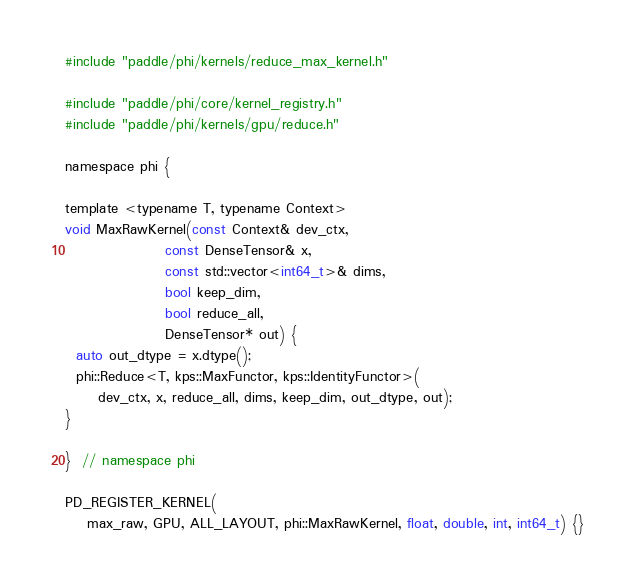<code> <loc_0><loc_0><loc_500><loc_500><_Cuda_>#include "paddle/phi/kernels/reduce_max_kernel.h"

#include "paddle/phi/core/kernel_registry.h"
#include "paddle/phi/kernels/gpu/reduce.h"

namespace phi {

template <typename T, typename Context>
void MaxRawKernel(const Context& dev_ctx,
                  const DenseTensor& x,
                  const std::vector<int64_t>& dims,
                  bool keep_dim,
                  bool reduce_all,
                  DenseTensor* out) {
  auto out_dtype = x.dtype();
  phi::Reduce<T, kps::MaxFunctor, kps::IdentityFunctor>(
      dev_ctx, x, reduce_all, dims, keep_dim, out_dtype, out);
}

}  // namespace phi

PD_REGISTER_KERNEL(
    max_raw, GPU, ALL_LAYOUT, phi::MaxRawKernel, float, double, int, int64_t) {}
</code> 